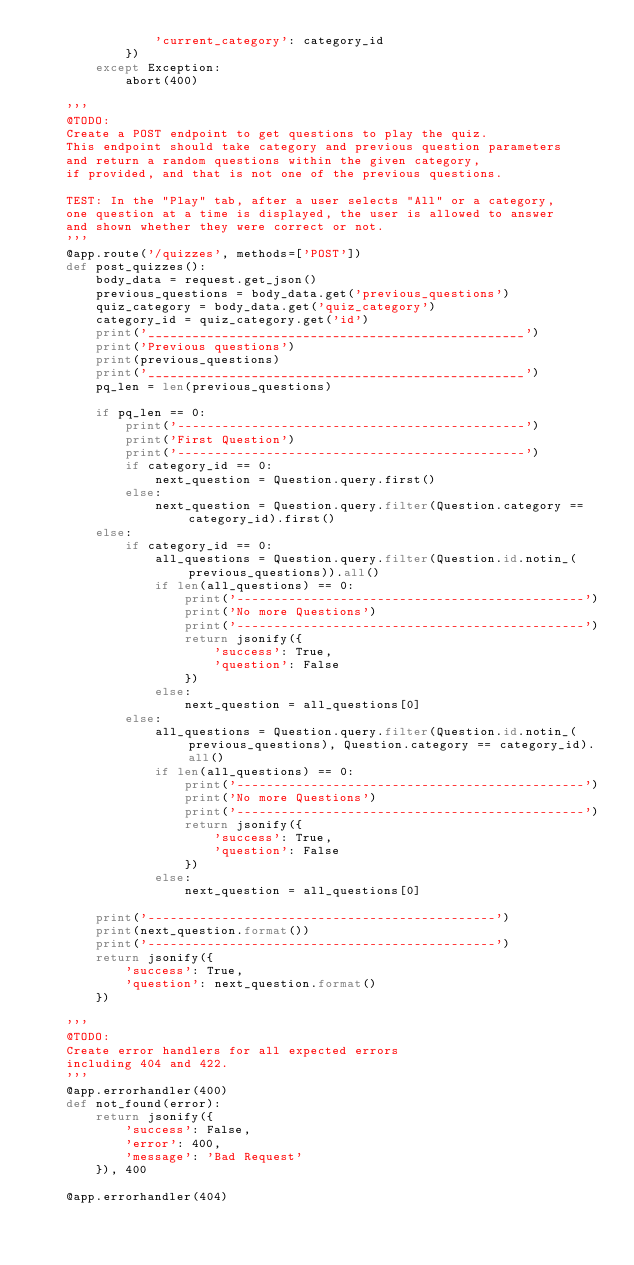Convert code to text. <code><loc_0><loc_0><loc_500><loc_500><_Python_>                'current_category': category_id
            })
        except Exception:
            abort(400)

    '''
    @TODO:
    Create a POST endpoint to get questions to play the quiz.
    This endpoint should take category and previous question parameters
    and return a random questions within the given category,
    if provided, and that is not one of the previous questions.

    TEST: In the "Play" tab, after a user selects "All" or a category,
    one question at a time is displayed, the user is allowed to answer
    and shown whether they were correct or not.
    '''
    @app.route('/quizzes', methods=['POST'])
    def post_quizzes():
        body_data = request.get_json()
        previous_questions = body_data.get('previous_questions')
        quiz_category = body_data.get('quiz_category')
        category_id = quiz_category.get('id')
        print('___________________________________________________')
        print('Previous questions')
        print(previous_questions)
        print('___________________________________________________')
        pq_len = len(previous_questions)

        if pq_len == 0:
            print('-----------------------------------------------')
            print('First Question')
            print('-----------------------------------------------')
            if category_id == 0:
                next_question = Question.query.first()
            else:
                next_question = Question.query.filter(Question.category == category_id).first()
        else:
            if category_id == 0:
                all_questions = Question.query.filter(Question.id.notin_(previous_questions)).all()
                if len(all_questions) == 0:
                    print('-----------------------------------------------')
                    print('No more Questions')
                    print('-----------------------------------------------')
                    return jsonify({
                        'success': True,
                        'question': False
                    })
                else:
                    next_question = all_questions[0]
            else:
                all_questions = Question.query.filter(Question.id.notin_(previous_questions), Question.category == category_id).all()
                if len(all_questions) == 0:
                    print('-----------------------------------------------')
                    print('No more Questions')
                    print('-----------------------------------------------')
                    return jsonify({
                        'success': True,
                        'question': False
                    })
                else:
                    next_question = all_questions[0]

        print('-----------------------------------------------')
        print(next_question.format())
        print('-----------------------------------------------')
        return jsonify({
            'success': True,
            'question': next_question.format()
        })

    '''
    @TODO:
    Create error handlers for all expected errors
    including 404 and 422.
    '''
    @app.errorhandler(400)
    def not_found(error):
        return jsonify({
            'success': False,
            'error': 400,
            'message': 'Bad Request'
        }), 400

    @app.errorhandler(404)</code> 